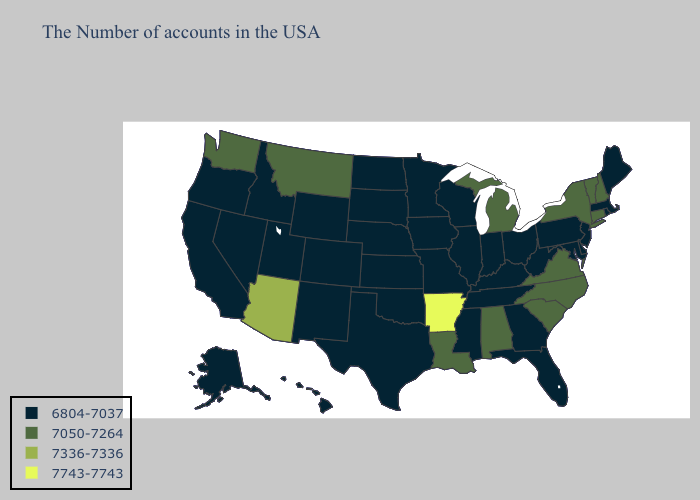Name the states that have a value in the range 7743-7743?
Concise answer only. Arkansas. What is the lowest value in the South?
Write a very short answer. 6804-7037. Name the states that have a value in the range 7336-7336?
Write a very short answer. Arizona. Name the states that have a value in the range 7743-7743?
Answer briefly. Arkansas. Among the states that border South Carolina , does North Carolina have the lowest value?
Concise answer only. No. Does Wyoming have the lowest value in the West?
Give a very brief answer. Yes. Is the legend a continuous bar?
Short answer required. No. Does the map have missing data?
Be succinct. No. Which states hav the highest value in the Northeast?
Short answer required. New Hampshire, Vermont, Connecticut, New York. Name the states that have a value in the range 7050-7264?
Short answer required. New Hampshire, Vermont, Connecticut, New York, Virginia, North Carolina, South Carolina, Michigan, Alabama, Louisiana, Montana, Washington. Name the states that have a value in the range 6804-7037?
Short answer required. Maine, Massachusetts, Rhode Island, New Jersey, Delaware, Maryland, Pennsylvania, West Virginia, Ohio, Florida, Georgia, Kentucky, Indiana, Tennessee, Wisconsin, Illinois, Mississippi, Missouri, Minnesota, Iowa, Kansas, Nebraska, Oklahoma, Texas, South Dakota, North Dakota, Wyoming, Colorado, New Mexico, Utah, Idaho, Nevada, California, Oregon, Alaska, Hawaii. What is the value of North Carolina?
Give a very brief answer. 7050-7264. Among the states that border North Dakota , which have the highest value?
Write a very short answer. Montana. Which states hav the highest value in the South?
Quick response, please. Arkansas. Name the states that have a value in the range 7336-7336?
Give a very brief answer. Arizona. 